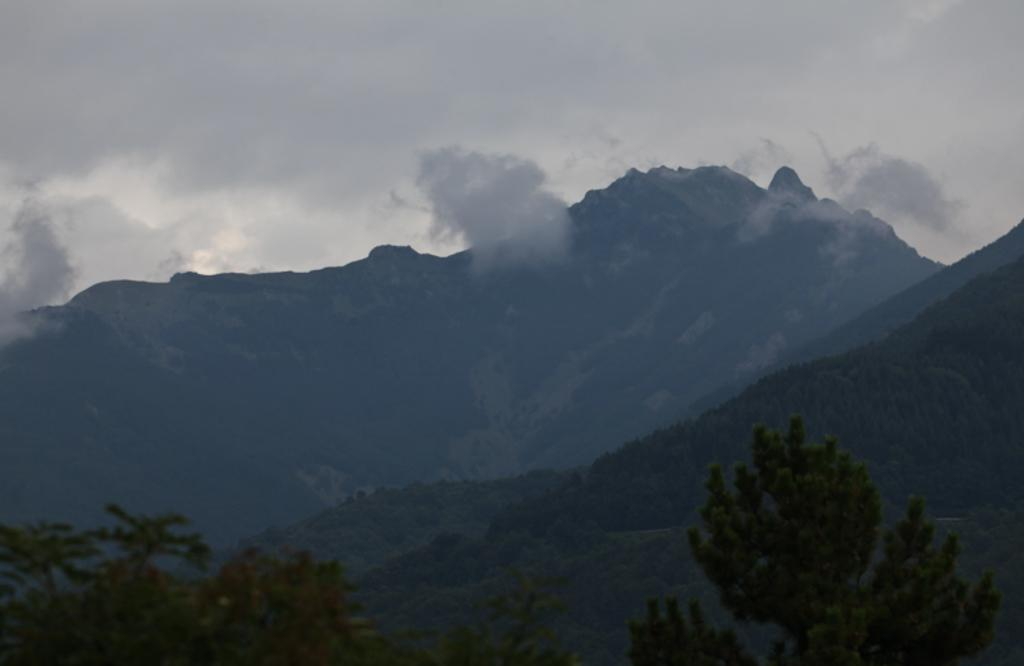What type of vegetation can be seen in the image? There are trees in the image. What geographical features are present in the image? There are hills in the image. What can be seen in the sky in the image? There are clouds in the image. What type of hair can be seen on the trees in the image? There is no hair present on the trees in the image; they are simply trees with leaves or branches. 